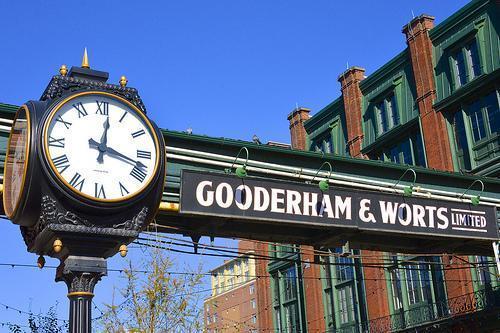How many clocks are there?
Give a very brief answer. 1. 